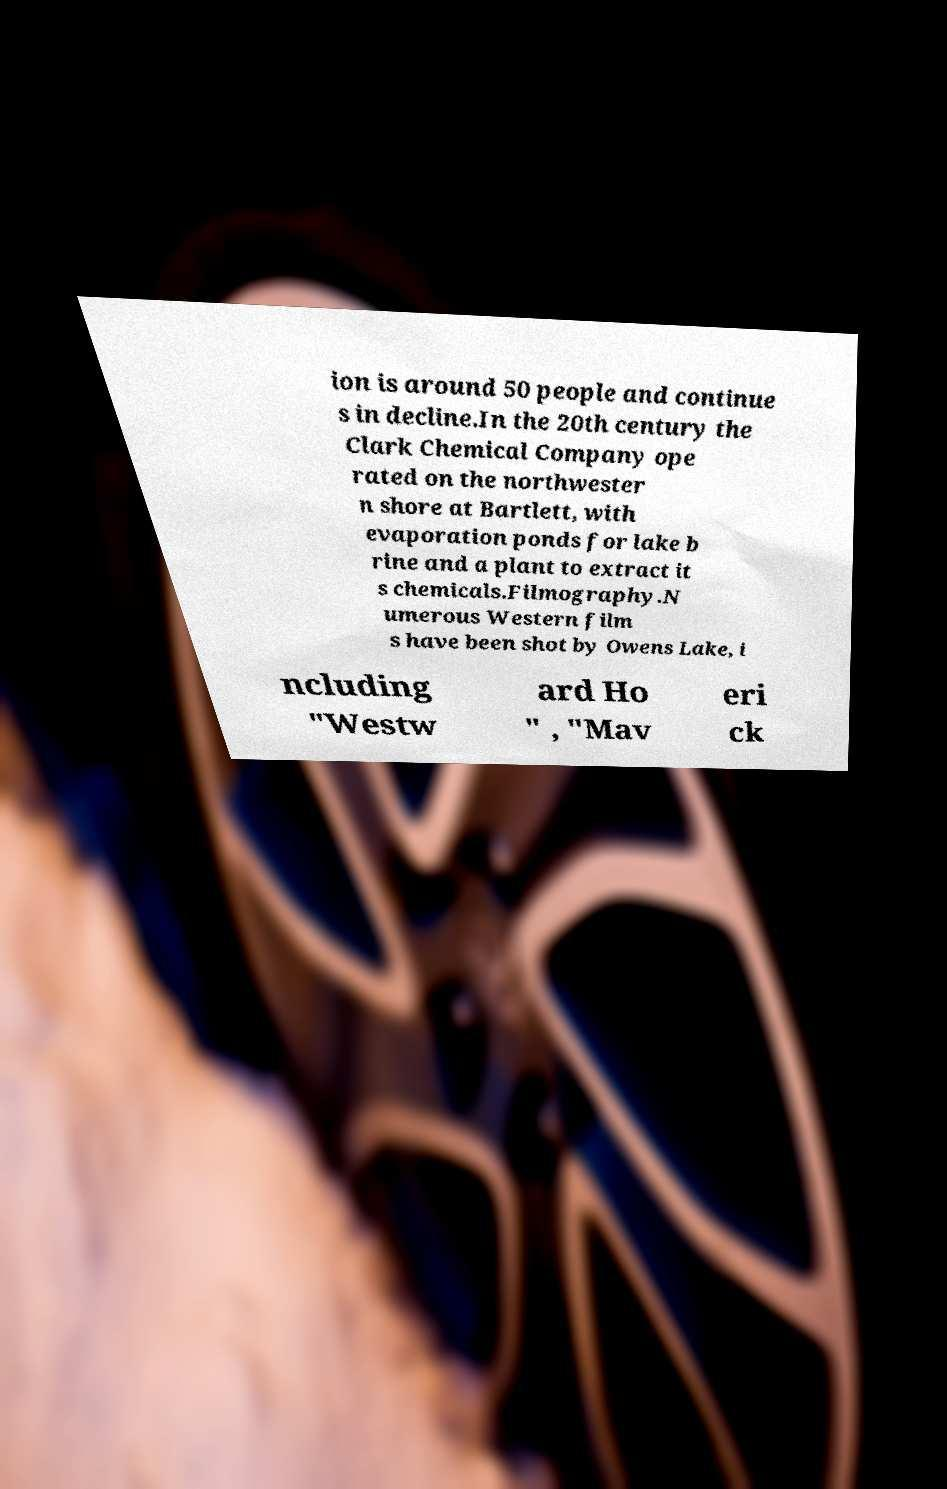Can you accurately transcribe the text from the provided image for me? ion is around 50 people and continue s in decline.In the 20th century the Clark Chemical Company ope rated on the northwester n shore at Bartlett, with evaporation ponds for lake b rine and a plant to extract it s chemicals.Filmography.N umerous Western film s have been shot by Owens Lake, i ncluding "Westw ard Ho " , "Mav eri ck 